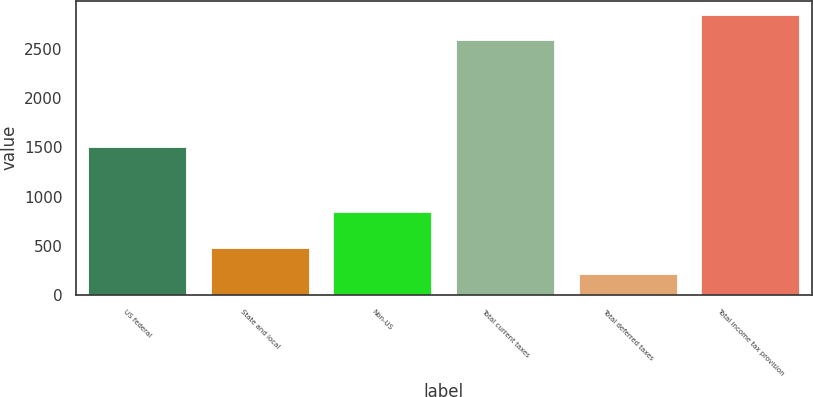Convert chart. <chart><loc_0><loc_0><loc_500><loc_500><bar_chart><fcel>US federal<fcel>State and local<fcel>Non-US<fcel>Total current taxes<fcel>Total deferred taxes<fcel>Total income tax provision<nl><fcel>1504<fcel>473<fcel>843<fcel>2590<fcel>214<fcel>2849<nl></chart> 